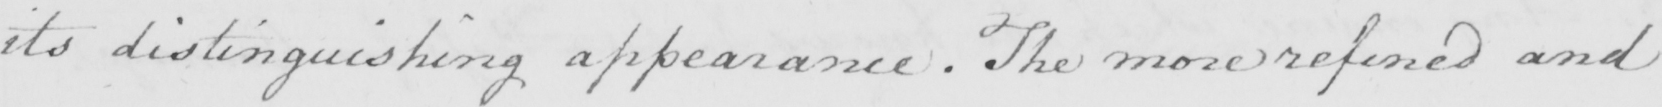Please transcribe the handwritten text in this image. its distinguishing appearance . The more refined and 